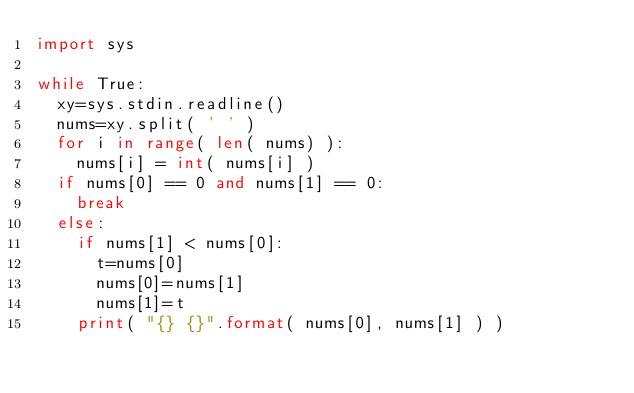Convert code to text. <code><loc_0><loc_0><loc_500><loc_500><_Python_>import sys

while True:
	xy=sys.stdin.readline()
	nums=xy.split( ' ' )
	for i in range( len( nums) ):
		nums[i] = int( nums[i] )
	if nums[0] == 0 and nums[1] == 0:
		break
	else:
		if nums[1] < nums[0]:
			t=nums[0]
			nums[0]=nums[1]
			nums[1]=t
		print( "{} {}".format( nums[0], nums[1] ) )</code> 